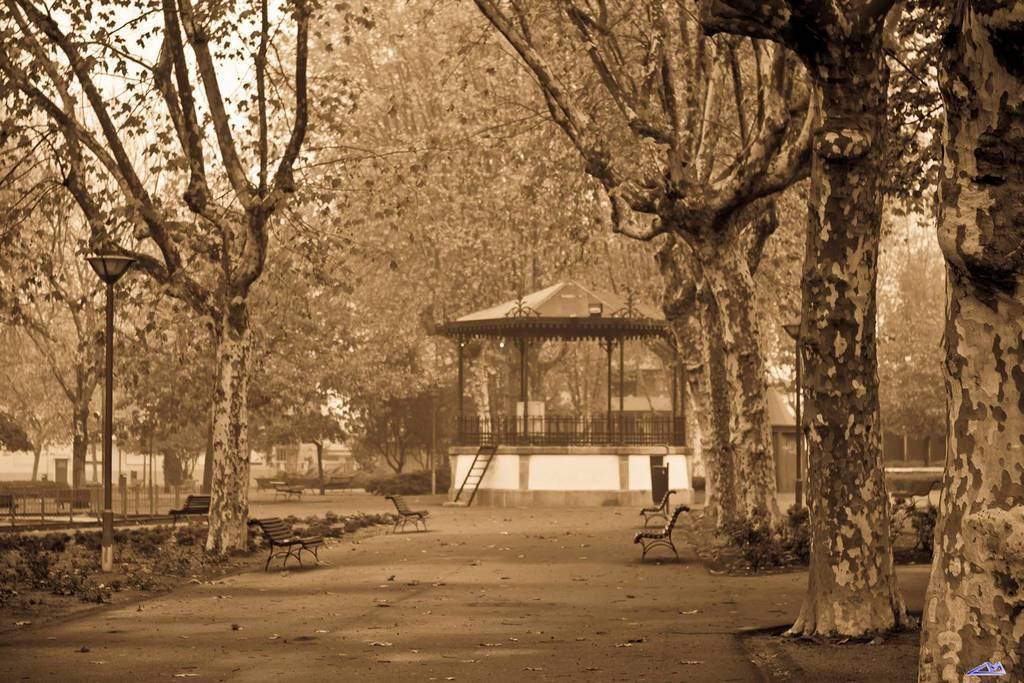Describe this image in one or two sentences. Here we can see light poles, benches, plants and trees. Under this open shed we can see poles and railing. Far there is a ladder. 